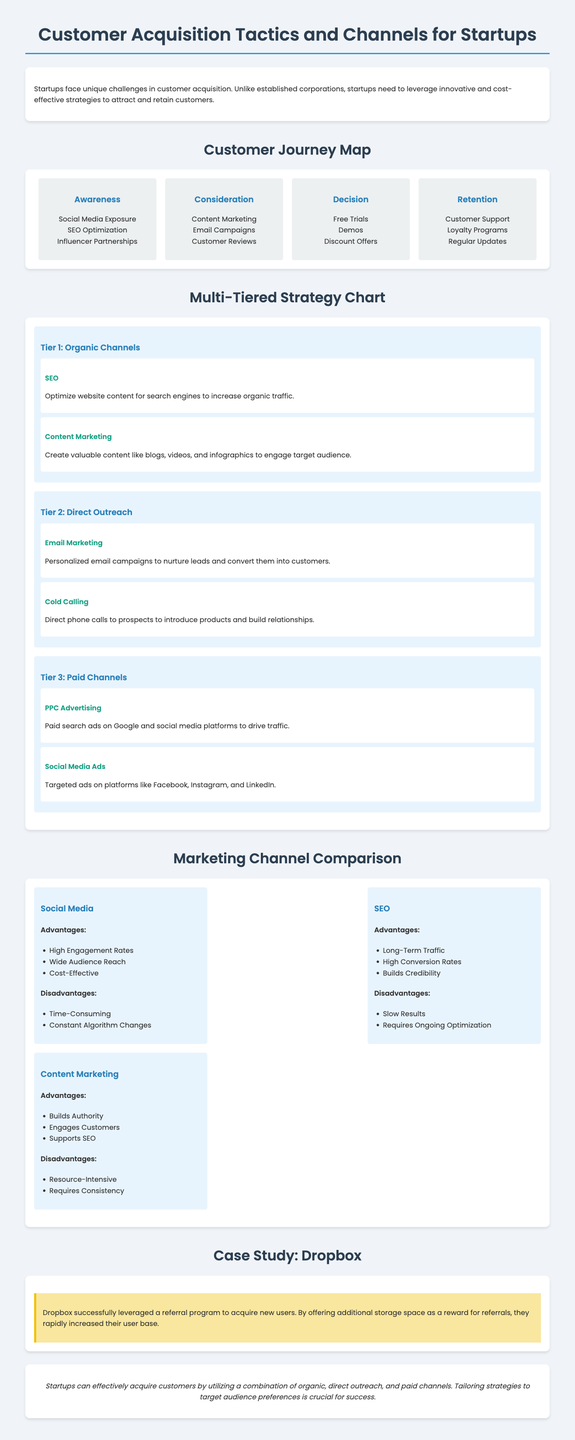What are the four stages of the customer journey? The customer journey is divided into four stages: Awareness, Consideration, Decision, and Retention.
Answer: Awareness, Consideration, Decision, Retention What is one of the strategies listed under Tier 1: Organic Channels? The strategies listed under Tier 1 include SEO and Content Marketing, with SEO being a key example.
Answer: SEO Which social media advantage highlights cost-effectiveness? The advantages of social media include High Engagement Rates, Wide Audience Reach, and Cost-Effective; "Cost-Effective" specifically addresses cost.
Answer: Cost-Effective What case study is mentioned in the infographic? The infographic mentions Dropbox as a case study illustrating successful customer acquisition tactics.
Answer: Dropbox What type of marketing does a referral program typically fall under? The referral program used by Dropbox exemplifies Direct Outreach strategies in customer acquisition.
Answer: Direct Outreach What is one disadvantage of SEO listed in the document? One disadvantage of SEO mentioned is "Slow Results," indicating a lag in effectiveness.
Answer: Slow Results What tactic does the Decision stage focus on? The Decision stage includes tactics like Free Trials, Demos, and Discount Offers, making it crucial for conversion.
Answer: Free Trials In which section can you find information about customer support strategies? Customer support strategies are discussed under the Retention stage of the customer journey.
Answer: Retention What tier involves paid advertising channels? Paid Channels are identified as Tier 3 in the multi-tiered strategy chart.
Answer: Tier 3 